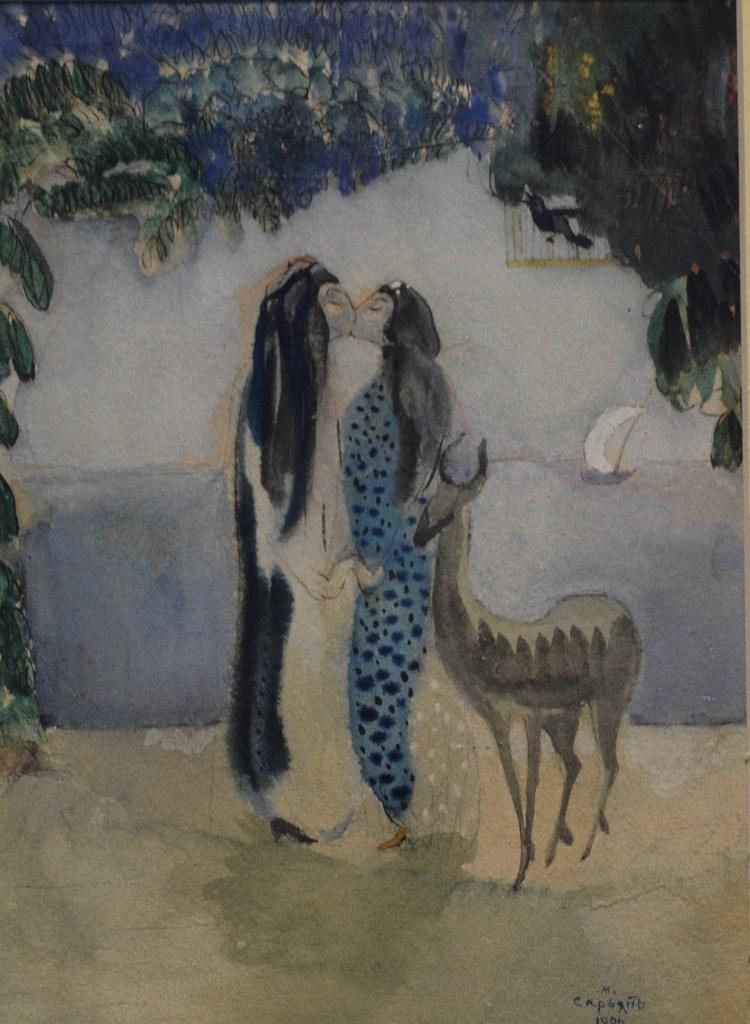What is the main subject of the image? The image contains an art piece. What is happening in the art piece? The art piece depicts two persons kissing each other. Are there any other elements in the art piece besides the two persons? Yes, there is an animal present in the art piece. What month does the art piece depict? The provided facts do not mention any specific month or time frame, so it cannot be determined from the image. How does the father in the art piece react to the two persons kissing? There is no mention of a father or any other family members in the art piece, so it cannot be determined from the image. 